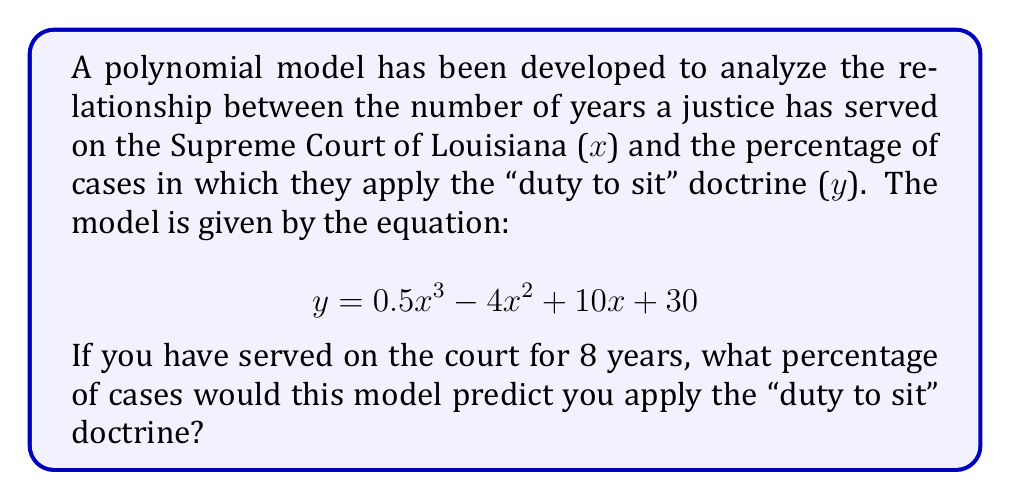Solve this math problem. To solve this problem, we need to evaluate the polynomial expression at x = 8. Let's break it down step-by-step:

1) The polynomial is: $y = 0.5x^3 - 4x^2 + 10x + 30$

2) Substitute x = 8 into the equation:
   $y = 0.5(8)^3 - 4(8)^2 + 10(8) + 30$

3) Evaluate the powers:
   $y = 0.5(512) - 4(64) + 10(8) + 30$

4) Multiply:
   $y = 256 - 256 + 80 + 30$

5) Add and subtract from left to right:
   $y = 0 + 80 + 30 = 110$

Therefore, according to this model, after serving 8 years on the court, you would be predicted to apply the "duty to sit" doctrine in 110% of cases.

Note: While mathematically correct, this result exceeds 100%, which is not possible in reality. This suggests that the model may not be accurate for values of x beyond a certain point, and its predictions should be interpreted cautiously.
Answer: 110% 